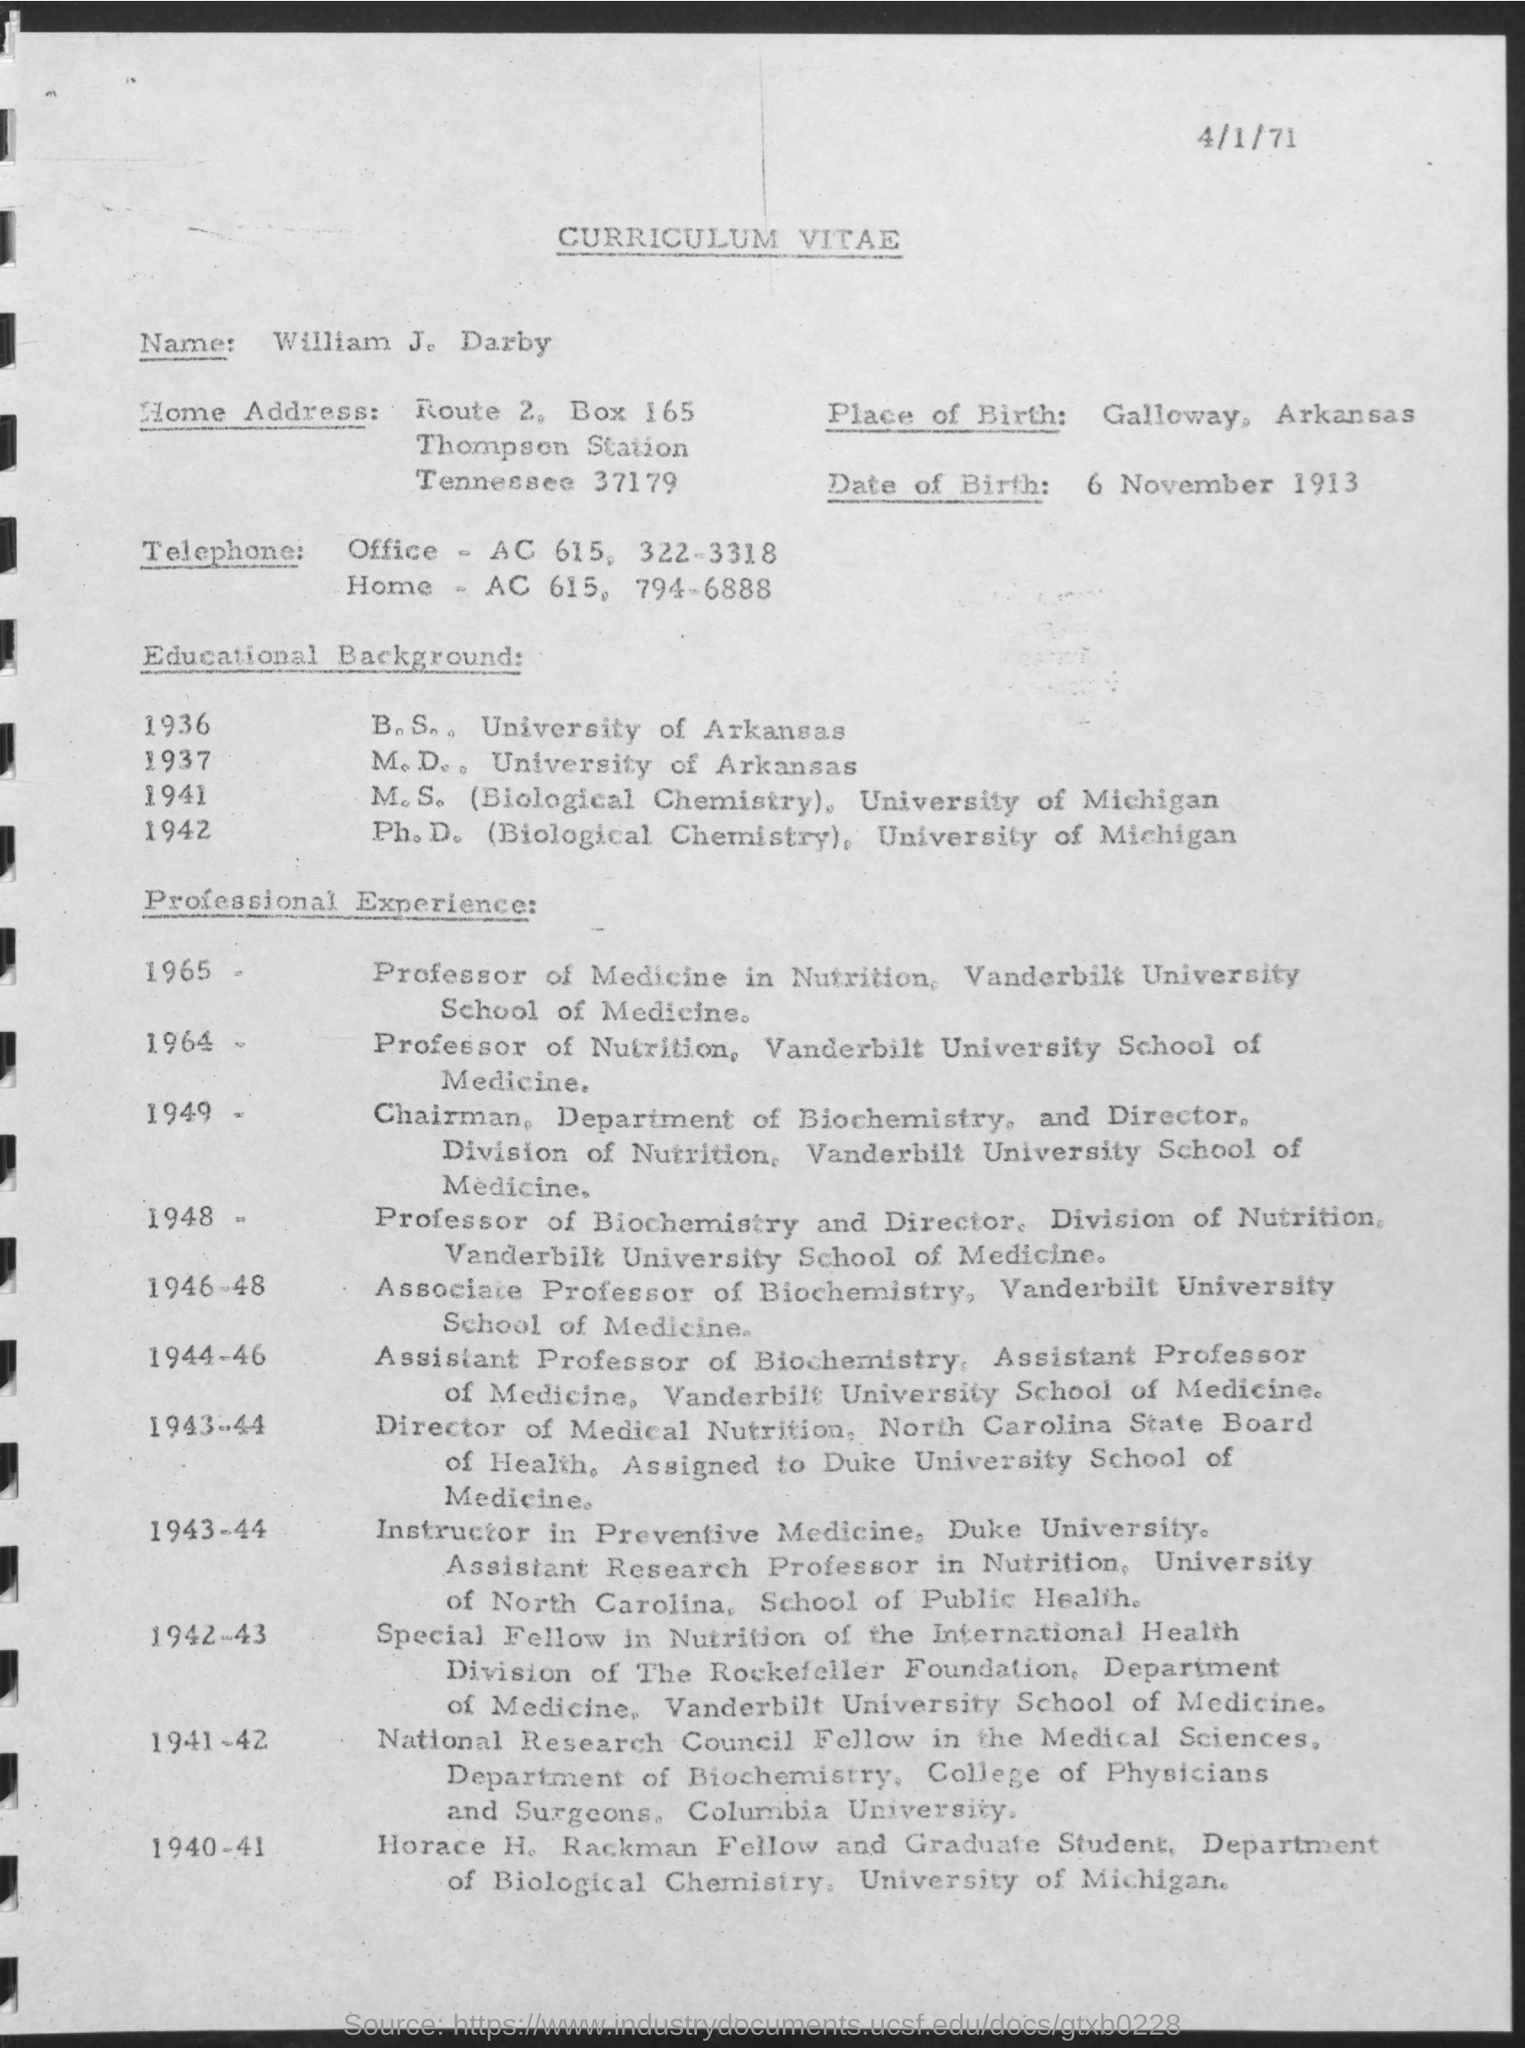Identify some key points in this picture. The letter head contains the phrase 'Curriculum Vitae'. The box number is 165. William was born on 6 November 1913. When he earned his Bachelor of Science degree in 1936, he had completed all the necessary requirements for the degree. The individual attended the University of Arkansas and earned a degree in medicine. 